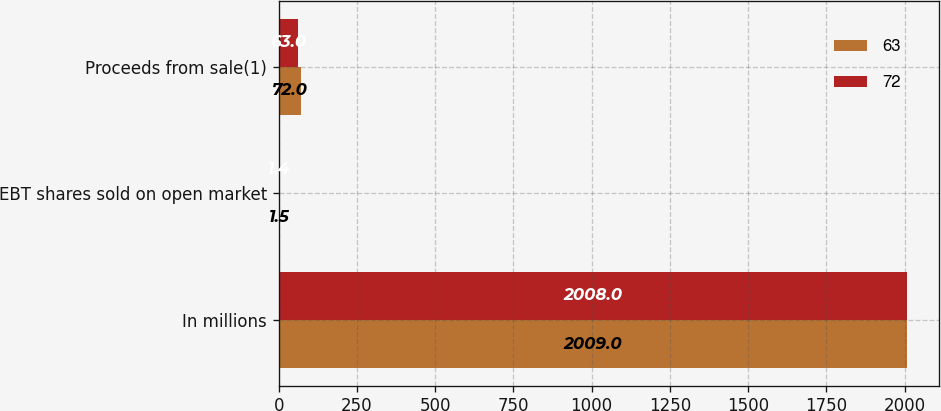Convert chart to OTSL. <chart><loc_0><loc_0><loc_500><loc_500><stacked_bar_chart><ecel><fcel>In millions<fcel>EBT shares sold on open market<fcel>Proceeds from sale(1)<nl><fcel>63<fcel>2009<fcel>1.5<fcel>72<nl><fcel>72<fcel>2008<fcel>1.4<fcel>63<nl></chart> 